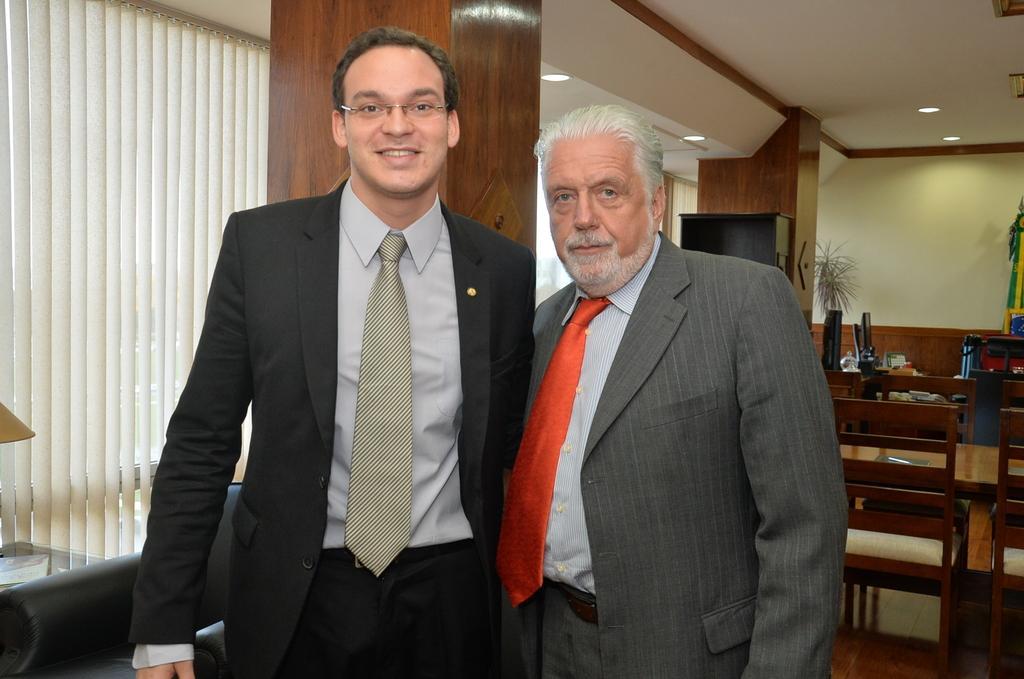Please provide a concise description of this image. This is an inside view. Here I can see two men standing, smiling and giving pose for the picture. On the right side there are few tables and chairs. On the tables few monitors, bottles and other objects are placed. In the background there is a pillar and windows. On the left side there is a lamp placed on a table and also there is a couch. At the top there are few lights. 